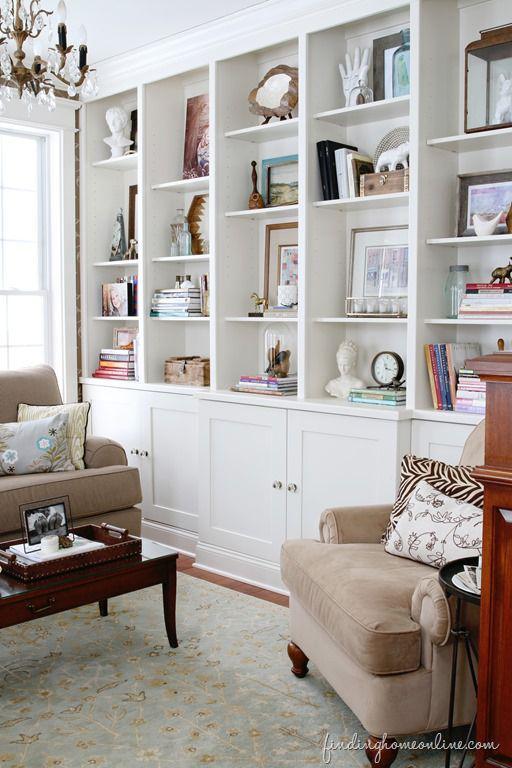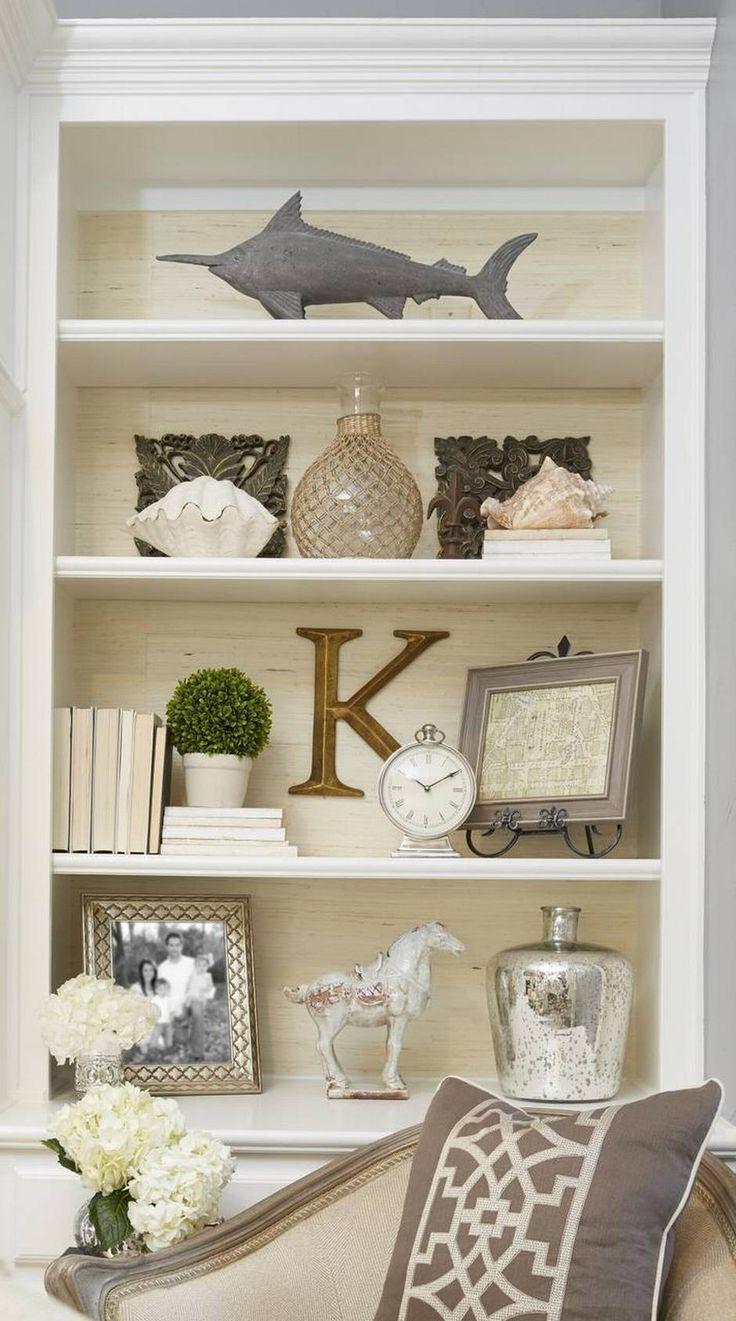The first image is the image on the left, the second image is the image on the right. Analyze the images presented: Is the assertion "A television hangs over the mantle in the image on the left." valid? Answer yes or no. No. 